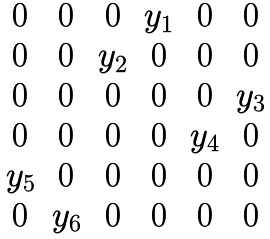Convert formula to latex. <formula><loc_0><loc_0><loc_500><loc_500>\begin{matrix} 0 & 0 & 0 & y _ { 1 } & 0 & 0 \\ 0 & 0 & y _ { 2 } & 0 & 0 & 0 \\ 0 & 0 & 0 & 0 & 0 & y _ { 3 } \\ 0 & 0 & 0 & 0 & y _ { 4 } & 0 \\ y _ { 5 } & 0 & 0 & 0 & 0 & 0 \\ 0 & y _ { 6 } & 0 & 0 & 0 & 0 \end{matrix}</formula> 